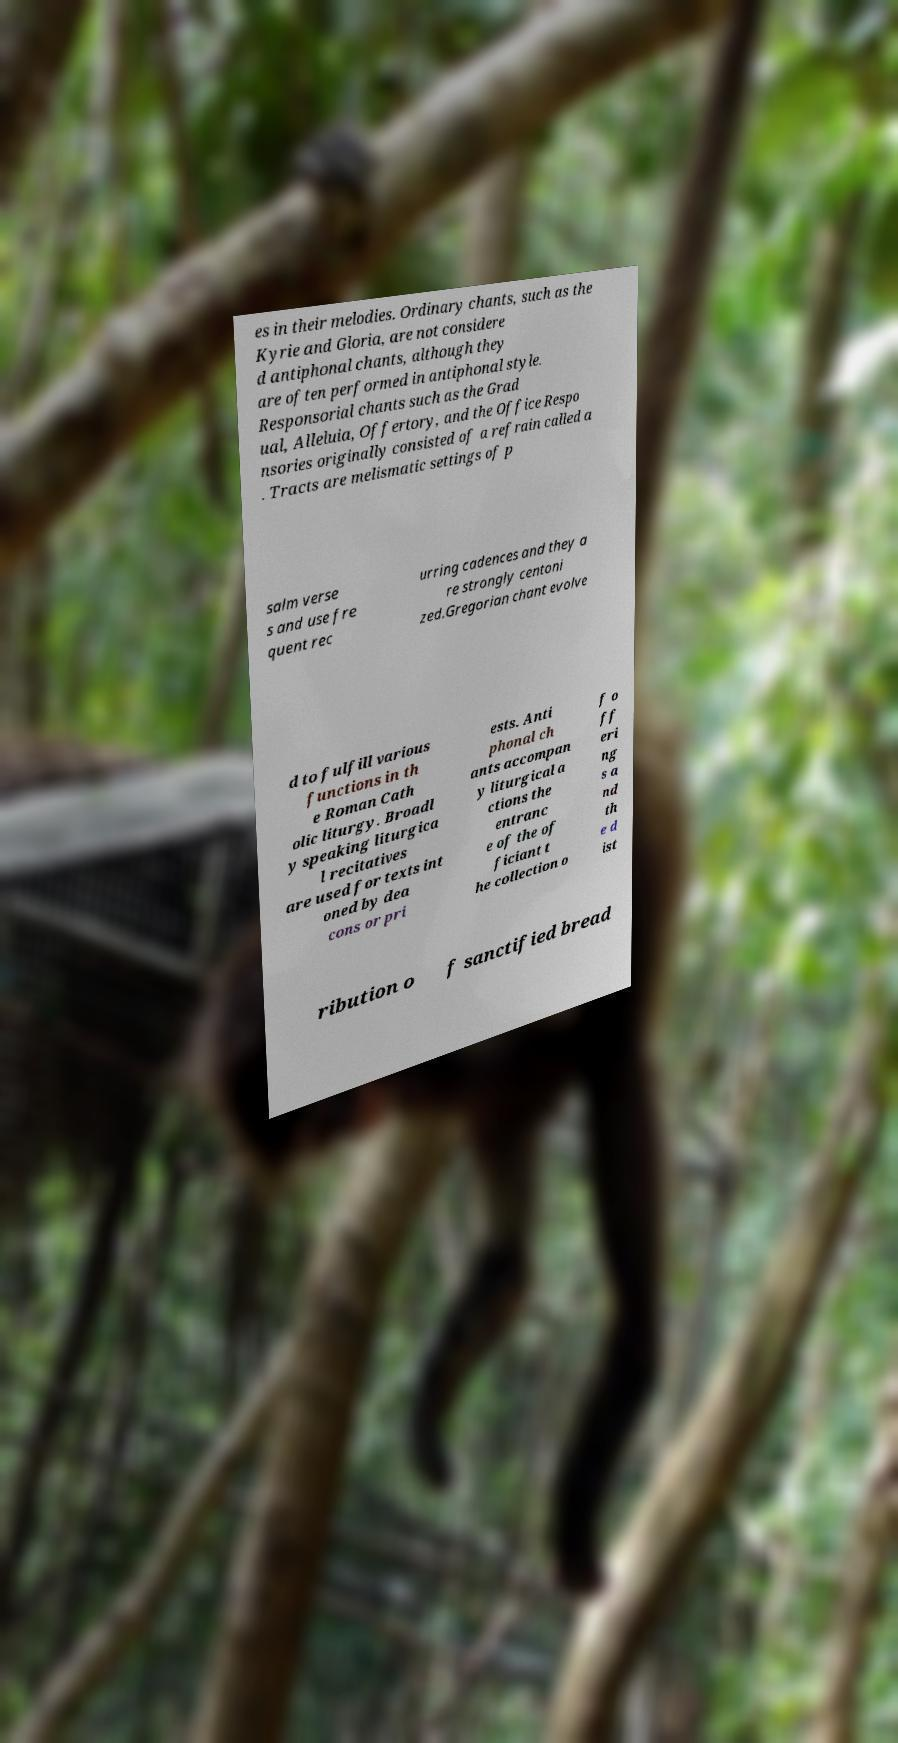Can you accurately transcribe the text from the provided image for me? es in their melodies. Ordinary chants, such as the Kyrie and Gloria, are not considere d antiphonal chants, although they are often performed in antiphonal style. Responsorial chants such as the Grad ual, Alleluia, Offertory, and the Office Respo nsories originally consisted of a refrain called a . Tracts are melismatic settings of p salm verse s and use fre quent rec urring cadences and they a re strongly centoni zed.Gregorian chant evolve d to fulfill various functions in th e Roman Cath olic liturgy. Broadl y speaking liturgica l recitatives are used for texts int oned by dea cons or pri ests. Anti phonal ch ants accompan y liturgical a ctions the entranc e of the of ficiant t he collection o f o ff eri ng s a nd th e d ist ribution o f sanctified bread 